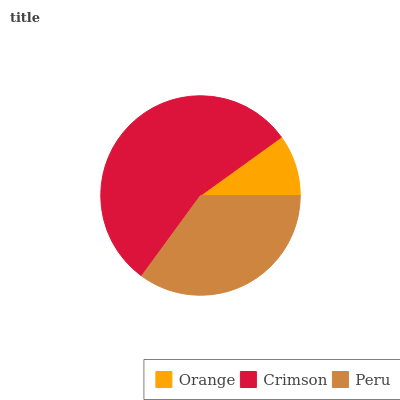Is Orange the minimum?
Answer yes or no. Yes. Is Crimson the maximum?
Answer yes or no. Yes. Is Peru the minimum?
Answer yes or no. No. Is Peru the maximum?
Answer yes or no. No. Is Crimson greater than Peru?
Answer yes or no. Yes. Is Peru less than Crimson?
Answer yes or no. Yes. Is Peru greater than Crimson?
Answer yes or no. No. Is Crimson less than Peru?
Answer yes or no. No. Is Peru the high median?
Answer yes or no. Yes. Is Peru the low median?
Answer yes or no. Yes. Is Crimson the high median?
Answer yes or no. No. Is Orange the low median?
Answer yes or no. No. 